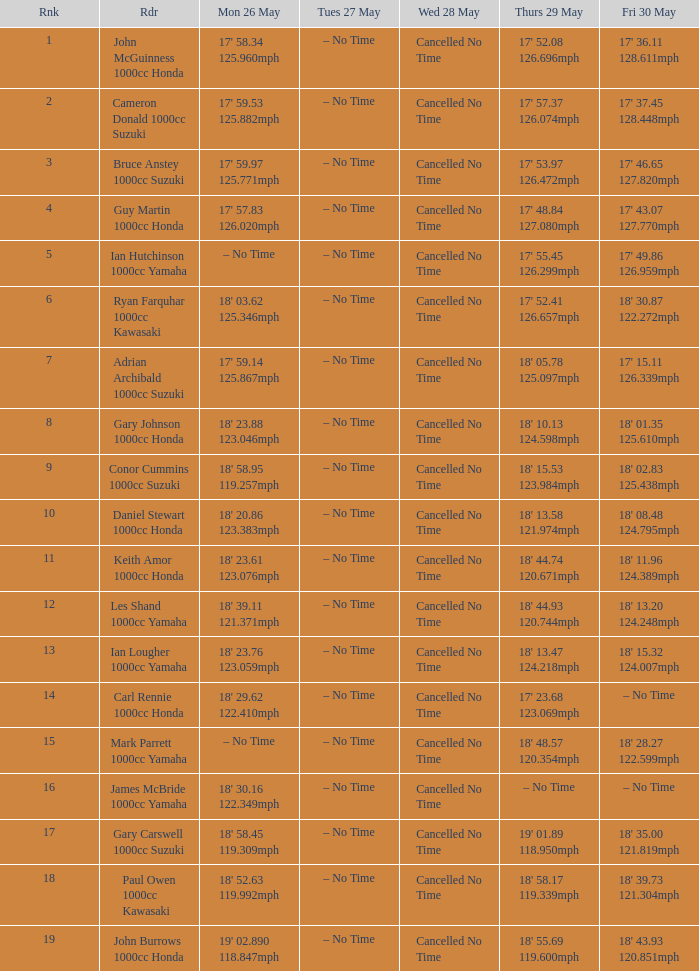890 11 18' 43.93 120.851mph. 